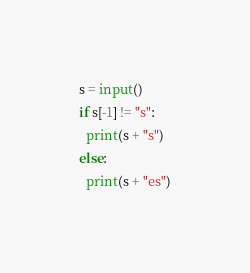Convert code to text. <code><loc_0><loc_0><loc_500><loc_500><_Python_>s = input()
if s[-1] != "s":
  print(s + "s")
else:
  print(s + "es")</code> 